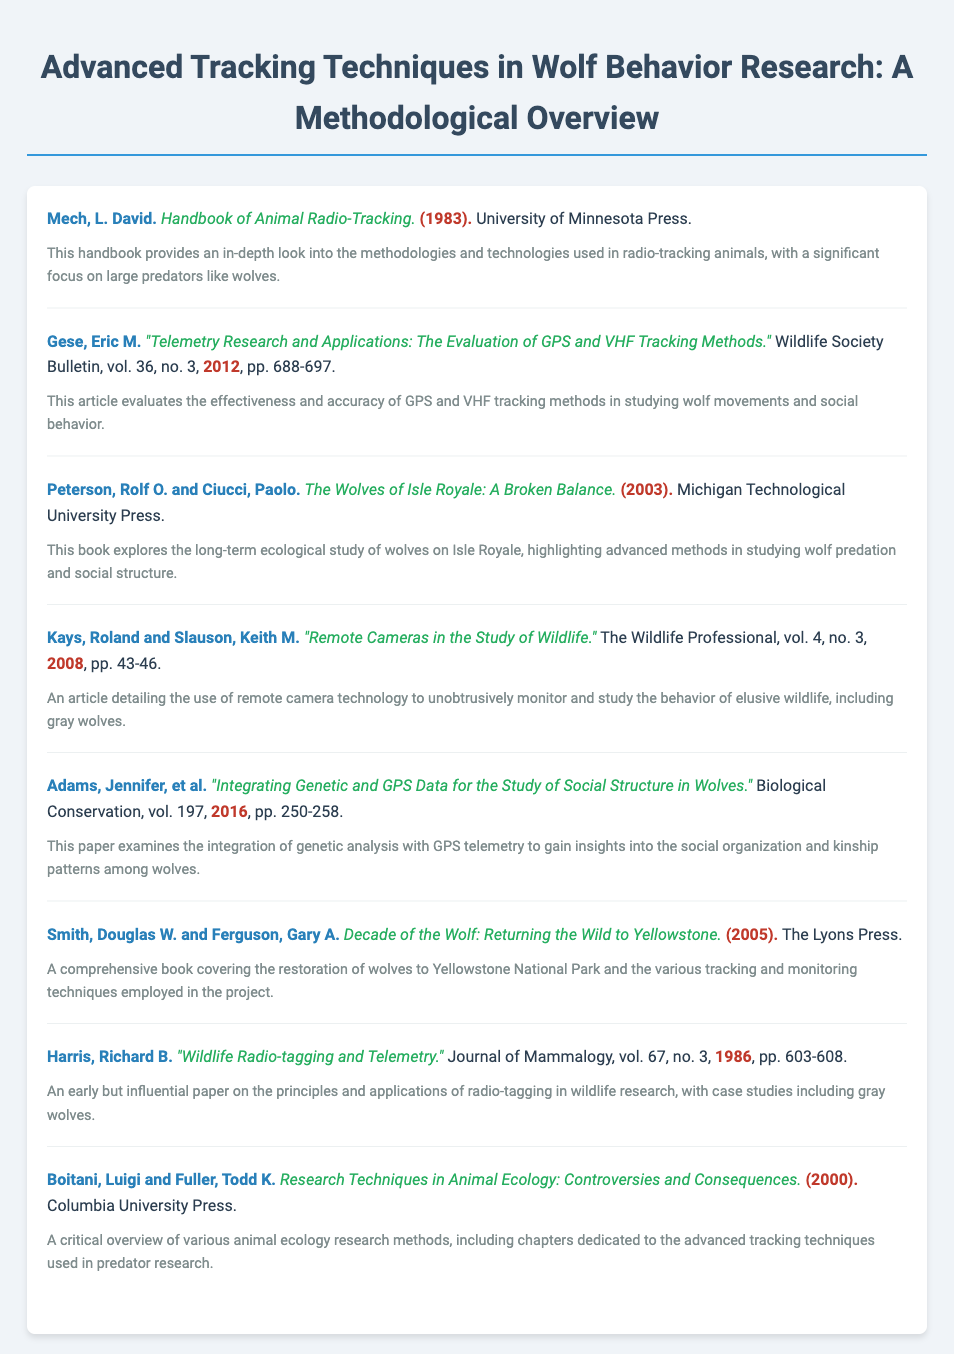What is the title of the document? The title is prominently displayed at the top of the document and summarizes its content.
Answer: Advanced Tracking Techniques in Wolf Behavior Research: A Methodological Overview Who authored the "Handbook of Animal Radio-Tracking"? The author is listed in the first entry of the bibliography and provides insight into radio-tracking methodologies.
Answer: Mech, L. David What year was "Integrating Genetic and GPS Data for the Study of Social Structure in Wolves" published? The publication year is specified with the article title in the bibliography.
Answer: 2016 How many pages does Gese's article cover? The pagination is provided in the citation details for his article in the bibliography.
Answer: pp. 688-697 What is the main focus of "Decade of the Wolf: Returning the Wild to Yellowstone"? The description highlights the tracking and monitoring techniques used in a specific project.
Answer: Restoration of wolves to Yellowstone National Park What method primarily discussed in Kays and Slauson's article? The title indicates the main technique used in their research on wildlife.
Answer: Remote camera technology Who are the authors of "The Wolves of Isle Royale: A Broken Balance"? The authors' names are listed in the citation for the book entry.
Answer: Peterson, Rolf O. and Ciucci, Paolo What type of publication is "Wildlife Radio-tagging and Telemetry"? The type of publication is indicated in the citation details for the respective article.
Answer: Journal of Mammalogy Which press published "Research Techniques in Animal Ecology: Controversies and Consequences"? The publishing house is listed in the citation for the book entry.
Answer: Columbia University Press 